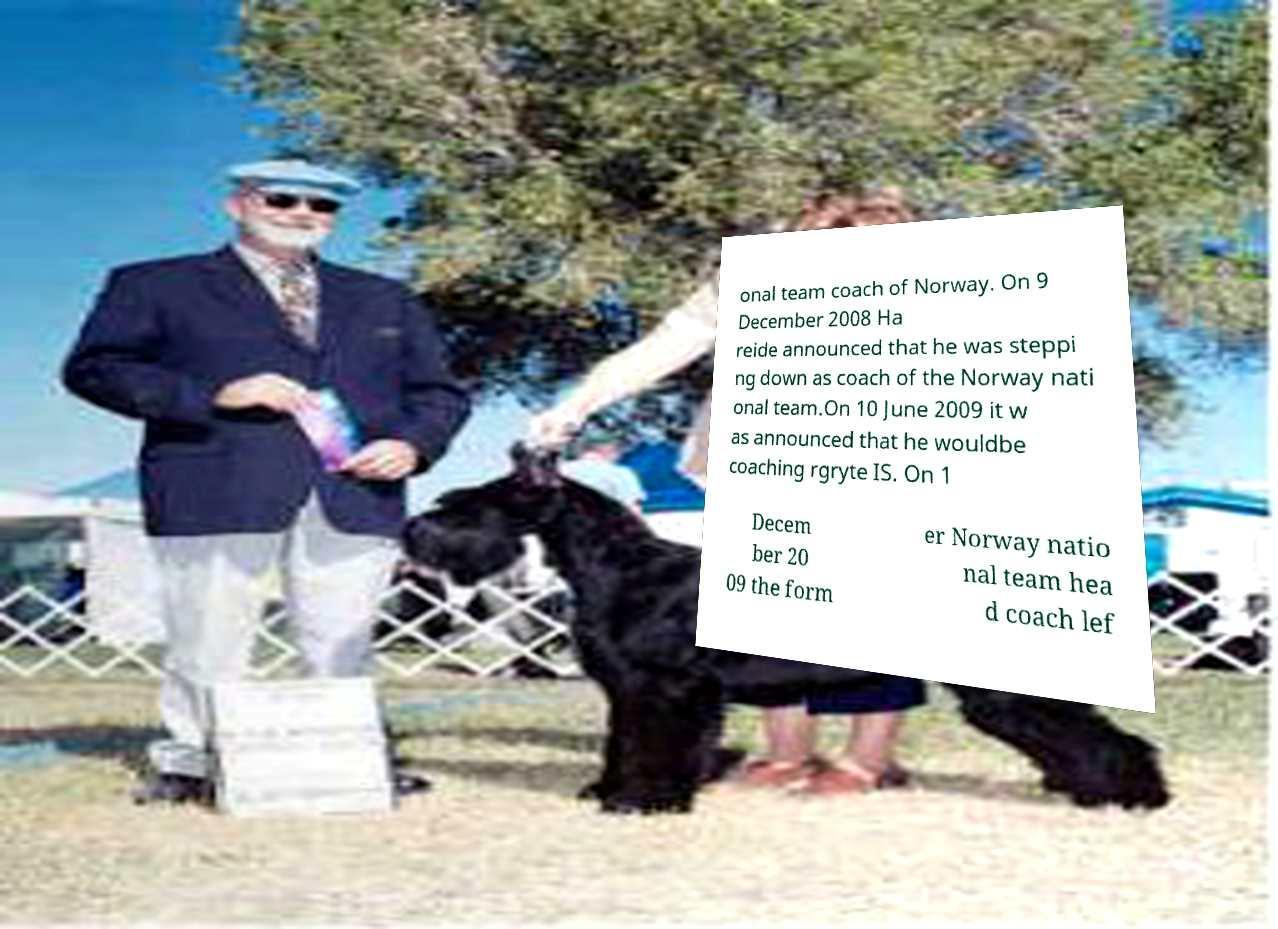Can you read and provide the text displayed in the image?This photo seems to have some interesting text. Can you extract and type it out for me? onal team coach of Norway. On 9 December 2008 Ha reide announced that he was steppi ng down as coach of the Norway nati onal team.On 10 June 2009 it w as announced that he wouldbe coaching rgryte IS. On 1 Decem ber 20 09 the form er Norway natio nal team hea d coach lef 